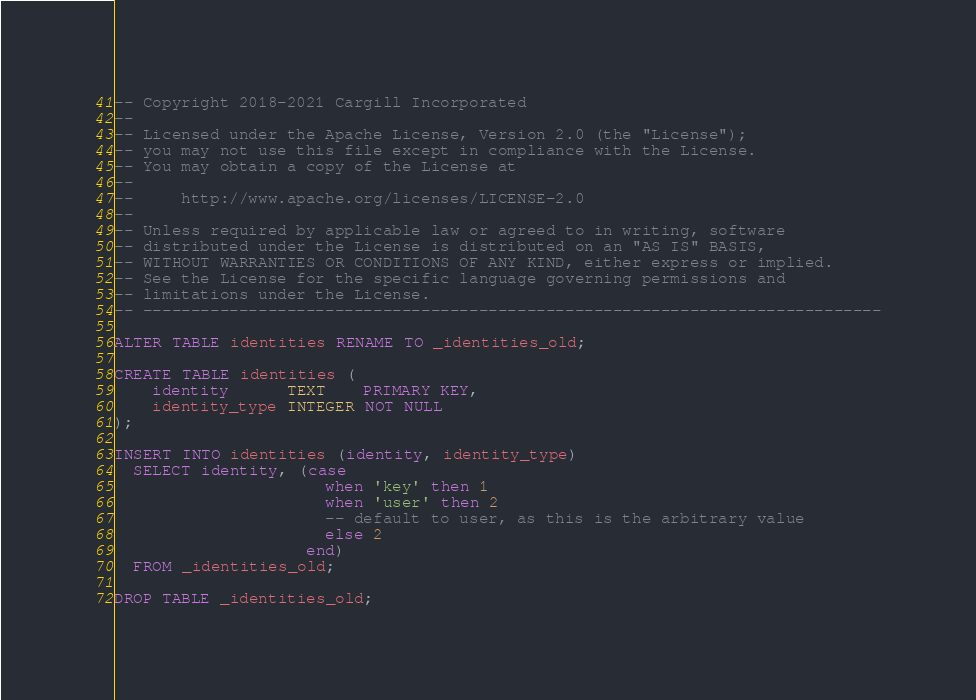<code> <loc_0><loc_0><loc_500><loc_500><_SQL_>-- Copyright 2018-2021 Cargill Incorporated
--
-- Licensed under the Apache License, Version 2.0 (the "License");
-- you may not use this file except in compliance with the License.
-- You may obtain a copy of the License at
--
--     http://www.apache.org/licenses/LICENSE-2.0
--
-- Unless required by applicable law or agreed to in writing, software
-- distributed under the License is distributed on an "AS IS" BASIS,
-- WITHOUT WARRANTIES OR CONDITIONS OF ANY KIND, either express or implied.
-- See the License for the specific language governing permissions and
-- limitations under the License.
-- -----------------------------------------------------------------------------

ALTER TABLE identities RENAME TO _identities_old;

CREATE TABLE identities (
    identity      TEXT    PRIMARY KEY,
    identity_type INTEGER NOT NULL
);

INSERT INTO identities (identity, identity_type)
  SELECT identity, (case
                      when 'key' then 1
                      when 'user' then 2
                      -- default to user, as this is the arbitrary value
                      else 2
                    end)
  FROM _identities_old;

DROP TABLE _identities_old;
</code> 